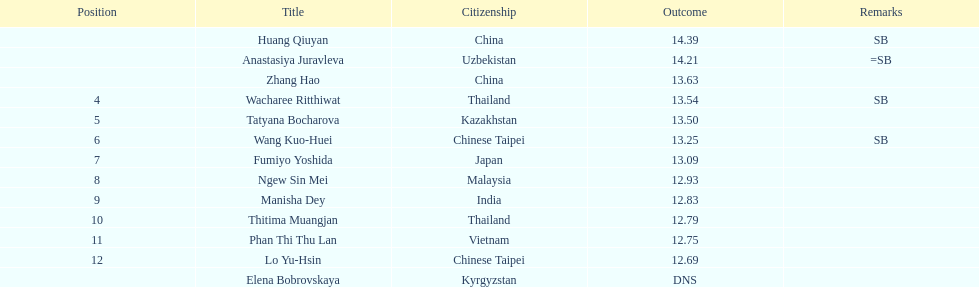The woman who took first place belonged to which nationality? China. 